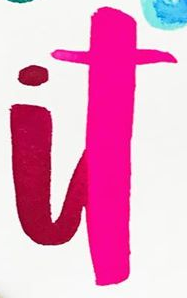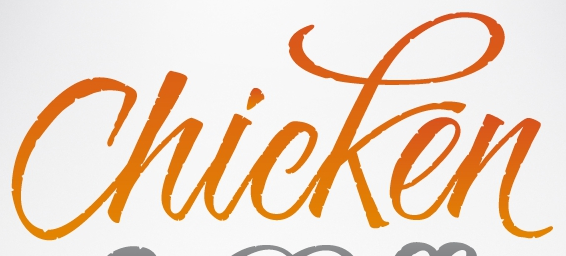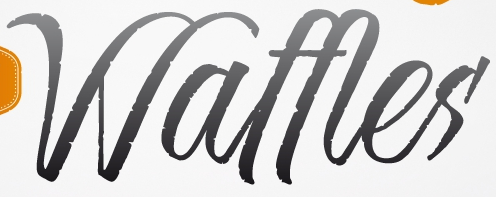Read the text from these images in sequence, separated by a semicolon. it; Chicken; Waffles 